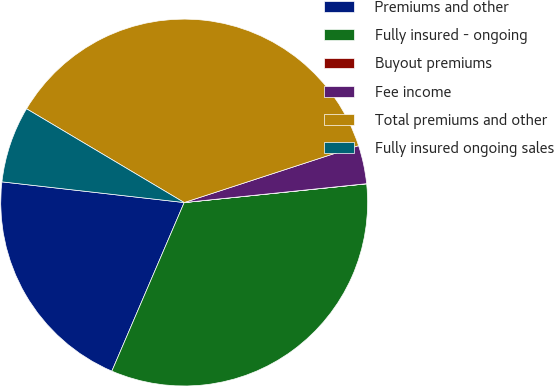Convert chart to OTSL. <chart><loc_0><loc_0><loc_500><loc_500><pie_chart><fcel>Premiums and other<fcel>Fully insured - ongoing<fcel>Buyout premiums<fcel>Fee income<fcel>Total premiums and other<fcel>Fully insured ongoing sales<nl><fcel>20.35%<fcel>33.08%<fcel>0.01%<fcel>3.38%<fcel>36.44%<fcel>6.74%<nl></chart> 